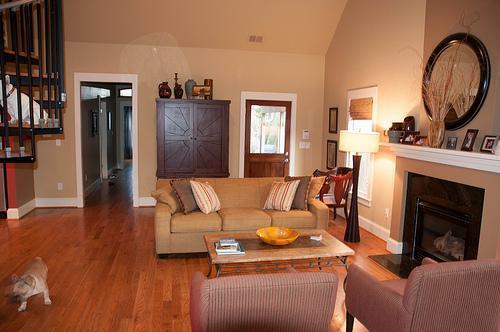How many pillows on the couch?
Give a very brief answer. 4. 